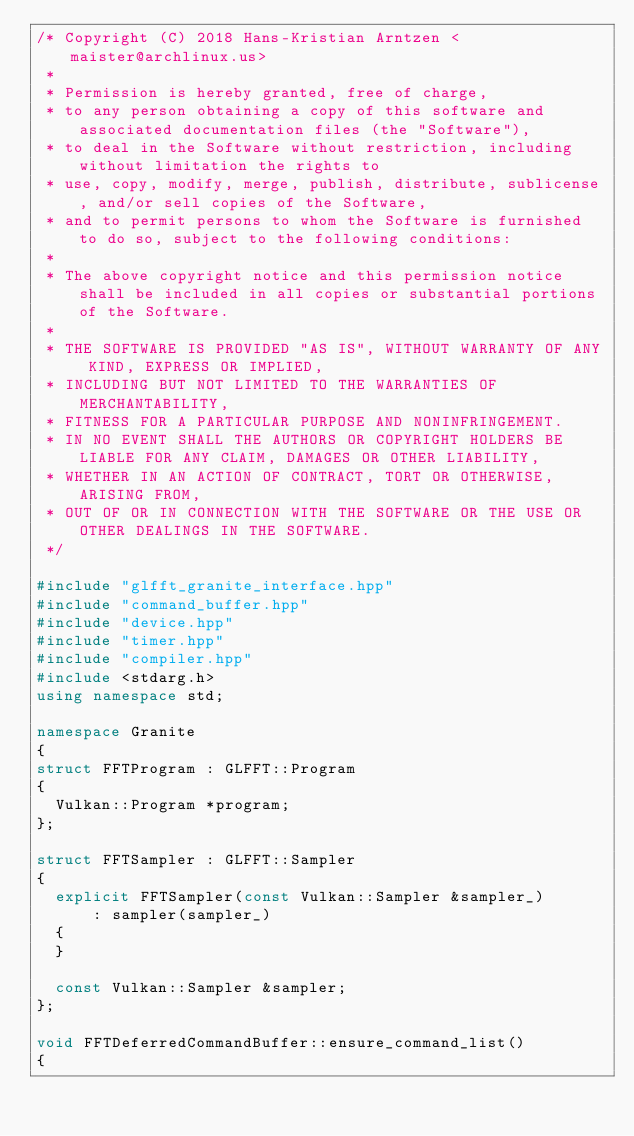<code> <loc_0><loc_0><loc_500><loc_500><_C++_>/* Copyright (C) 2018 Hans-Kristian Arntzen <maister@archlinux.us>
 *
 * Permission is hereby granted, free of charge,
 * to any person obtaining a copy of this software and associated documentation files (the "Software"),
 * to deal in the Software without restriction, including without limitation the rights to
 * use, copy, modify, merge, publish, distribute, sublicense, and/or sell copies of the Software,
 * and to permit persons to whom the Software is furnished to do so, subject to the following conditions:
 *
 * The above copyright notice and this permission notice shall be included in all copies or substantial portions of the Software.
 *
 * THE SOFTWARE IS PROVIDED "AS IS", WITHOUT WARRANTY OF ANY KIND, EXPRESS OR IMPLIED,
 * INCLUDING BUT NOT LIMITED TO THE WARRANTIES OF MERCHANTABILITY,
 * FITNESS FOR A PARTICULAR PURPOSE AND NONINFRINGEMENT.
 * IN NO EVENT SHALL THE AUTHORS OR COPYRIGHT HOLDERS BE LIABLE FOR ANY CLAIM, DAMAGES OR OTHER LIABILITY,
 * WHETHER IN AN ACTION OF CONTRACT, TORT OR OTHERWISE, ARISING FROM,
 * OUT OF OR IN CONNECTION WITH THE SOFTWARE OR THE USE OR OTHER DEALINGS IN THE SOFTWARE.
 */

#include "glfft_granite_interface.hpp"
#include "command_buffer.hpp"
#include "device.hpp"
#include "timer.hpp"
#include "compiler.hpp"
#include <stdarg.h>
using namespace std;

namespace Granite
{
struct FFTProgram : GLFFT::Program
{
	Vulkan::Program *program;
};

struct FFTSampler : GLFFT::Sampler
{
	explicit FFTSampler(const Vulkan::Sampler &sampler_)
	    : sampler(sampler_)
	{
	}

	const Vulkan::Sampler &sampler;
};

void FFTDeferredCommandBuffer::ensure_command_list()
{</code> 